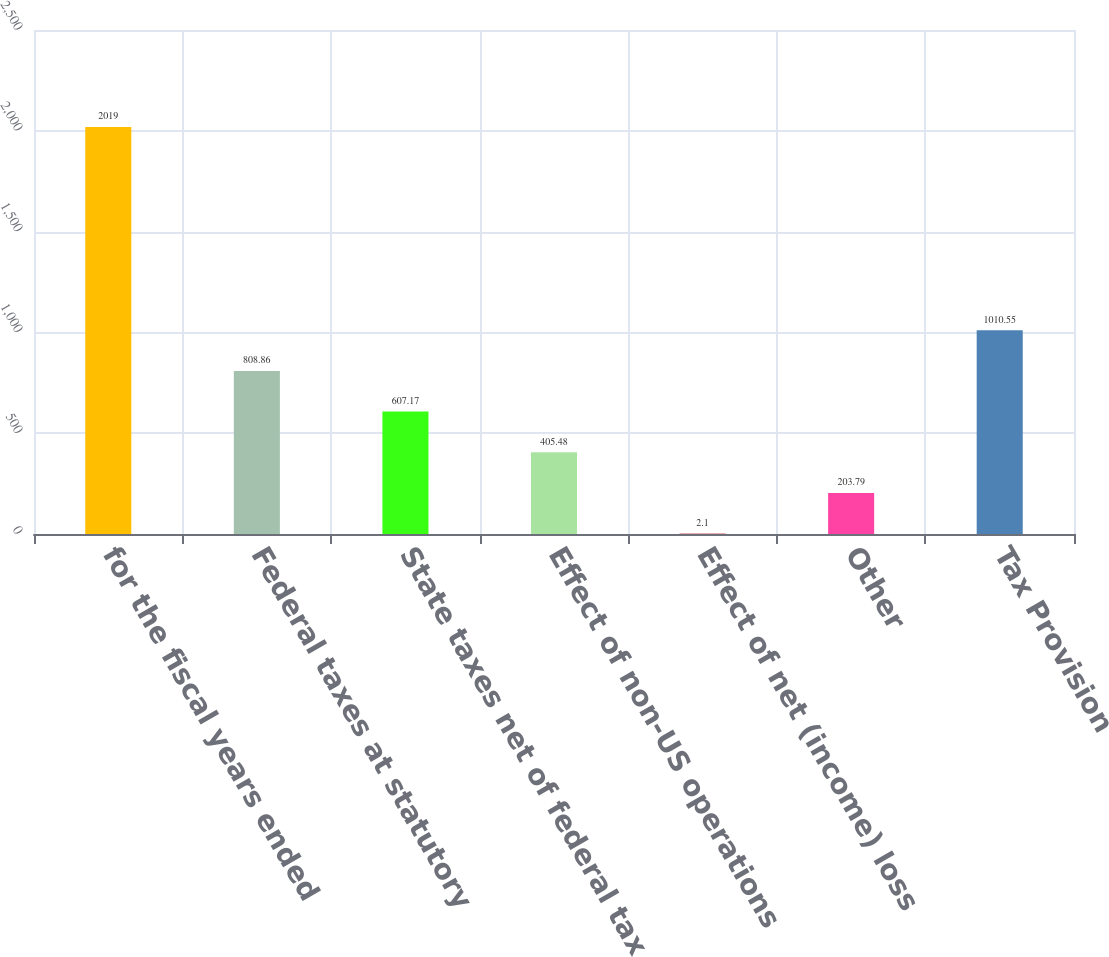Convert chart to OTSL. <chart><loc_0><loc_0><loc_500><loc_500><bar_chart><fcel>for the fiscal years ended<fcel>Federal taxes at statutory<fcel>State taxes net of federal tax<fcel>Effect of non-US operations<fcel>Effect of net (income) loss<fcel>Other<fcel>Tax Provision<nl><fcel>2019<fcel>808.86<fcel>607.17<fcel>405.48<fcel>2.1<fcel>203.79<fcel>1010.55<nl></chart> 